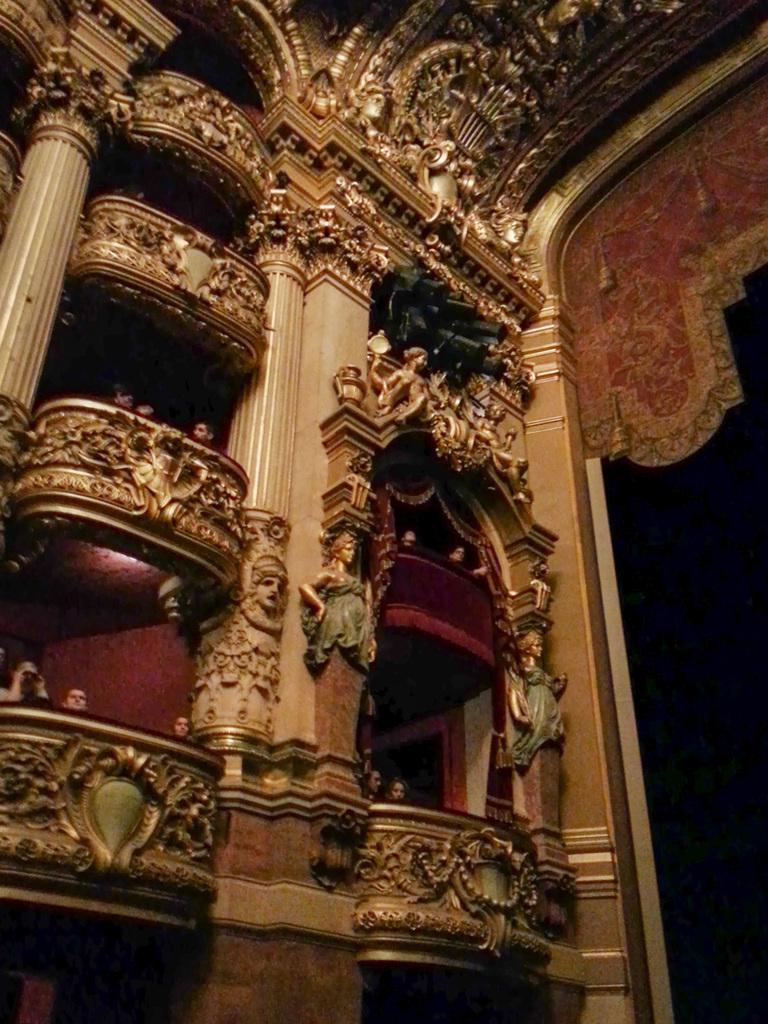Please provide a concise description of this image. In this image we can see an inside view of a building in which we can see group of people sitting, statues, pillars and dome lights. In the background we can see curtain. 